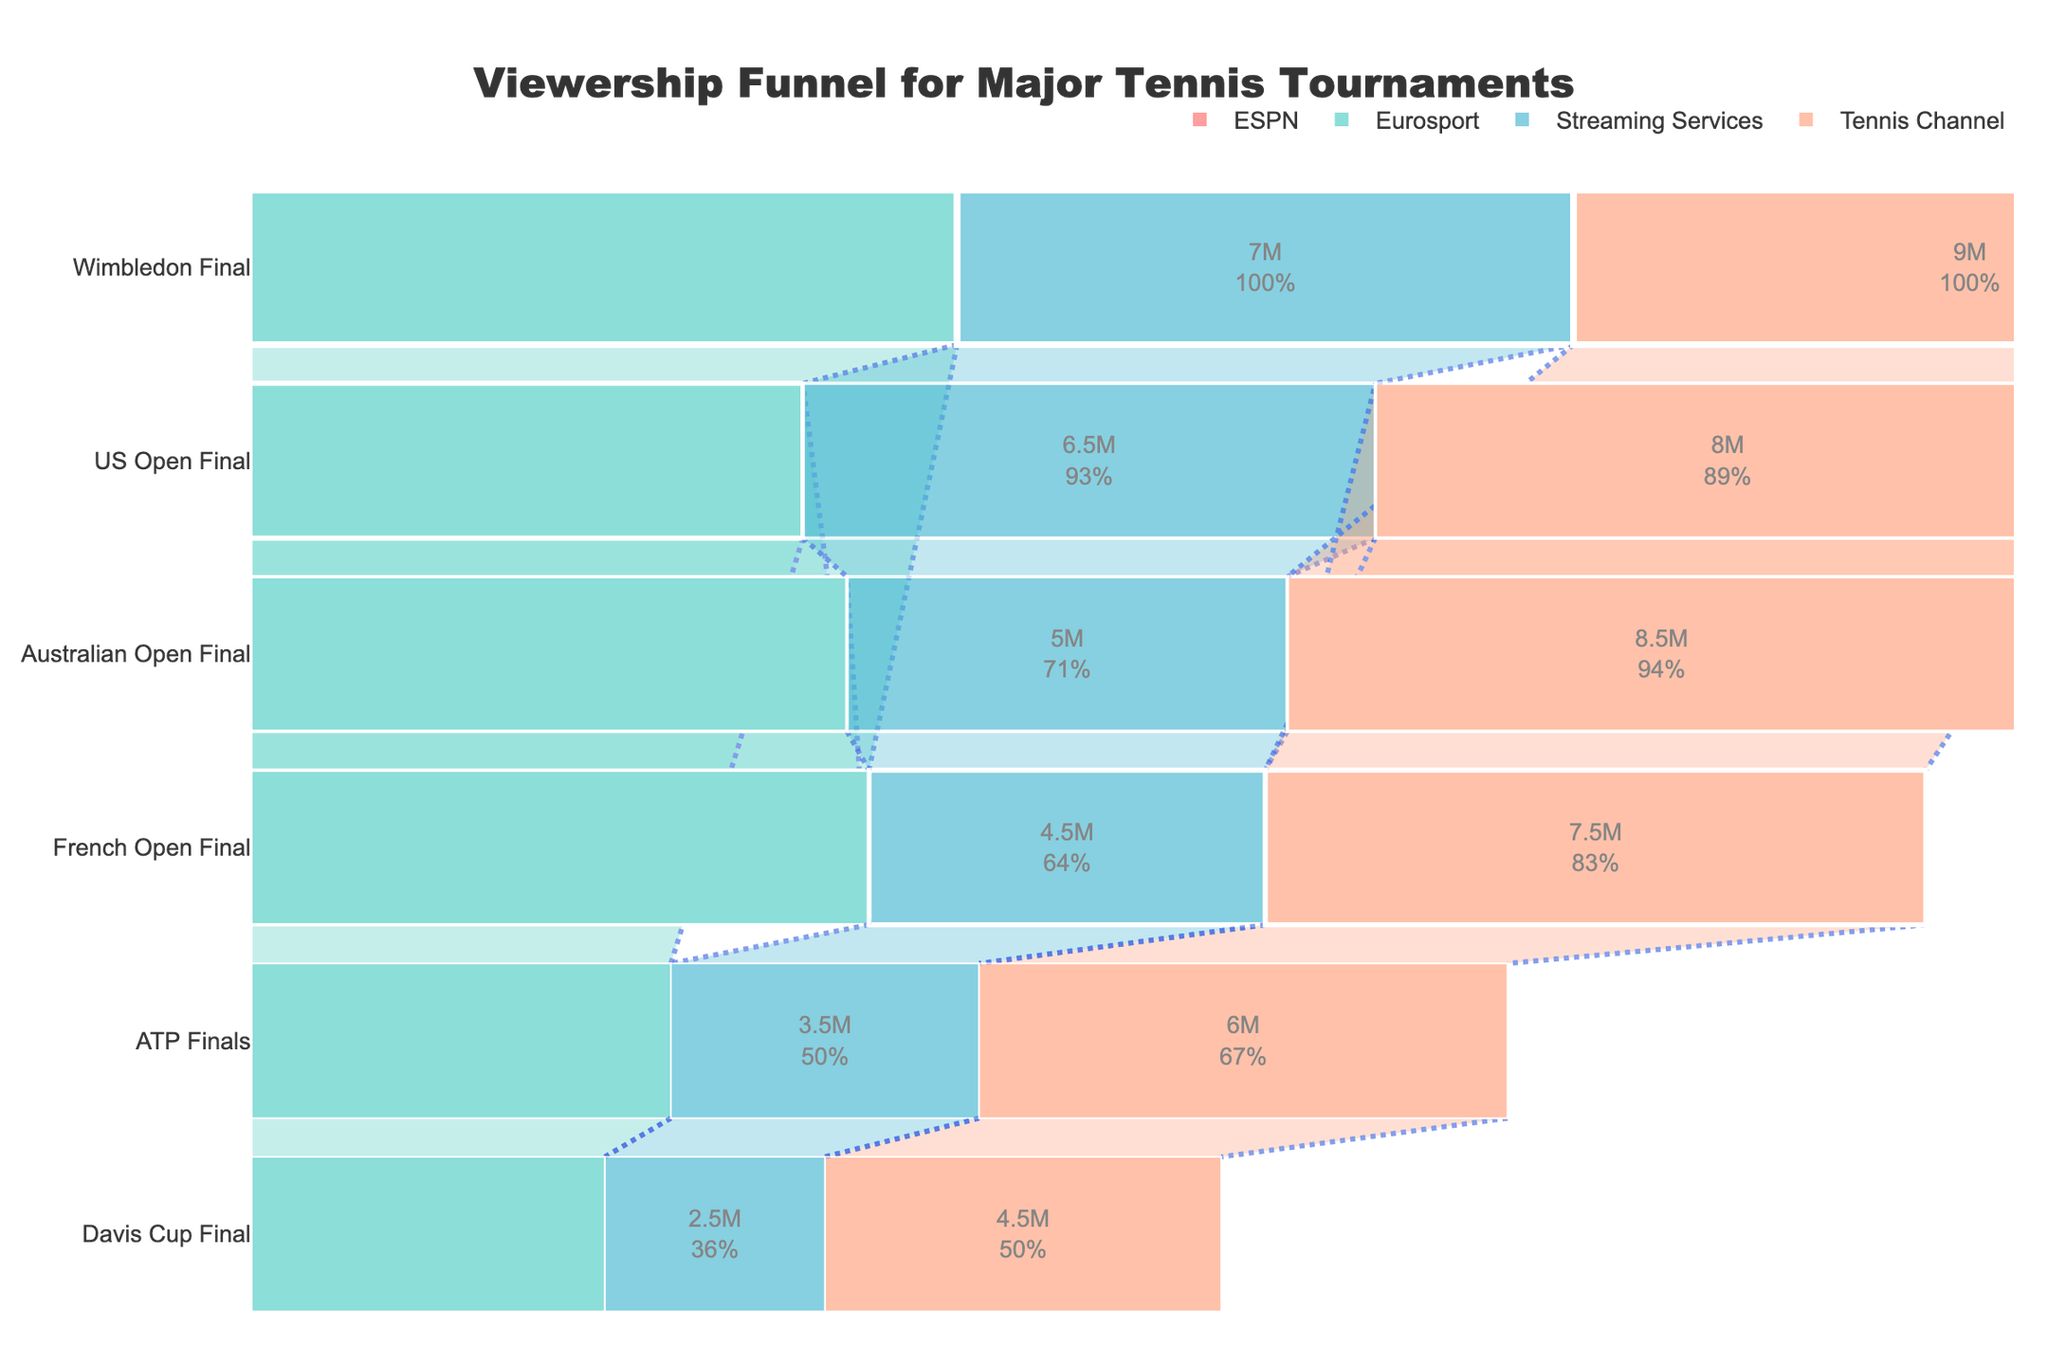which tournament had the highest viewership on Eurosport? First, observe the stages and their corresponding viewership values for Eurosport. The stage with the maximum viewership is the Wimbledon Final
Answer: Wimbledon Final what is the difference in viewership between the French Open Final and Davis Cup Final on ESPN? Identify the viewership of the French Open Final on ESPN (10,000,000) and the Davis Cup Final on ESPN (6,000,000). Subtract the later from the former: 10,000,000 - 6,000,000 = 4,000,000
Answer: 4,000,000 which broadcasting platform had the lowest viewership for the ATP Finals? For the ATP Finals, note the viewership across different platforms. The lowest value is on Streaming Services with 3,500,000
Answer: Streaming Services how many unique stages are shown in the funnel chart? Each stage represents a different tennis tournament's final. Counting the unique stages listed, we have Australian Open Final, Wimbledon Final, US Open Final, French Open Final, ATP Finals, and Davis Cup Final, which makes 6 unique stages
Answer: 6 which tournament had the most balanced viewership across all platforms? Examine viewership values for each platform for all tournaments. The US Open Final has relatively similar viewership numbers: ESPN (13,000,000), Tennis Channel (8,000,000), Eurosport (14,000,000), and Streaming Services (6,500,000), showing it's the most balanced
Answer: US Open Final what is the total viewership for the Wimbledon Final across all platforms? Sum the viewership of the Wimbledon Final from ESPN (14,000,000), Tennis Channel (9,000,000), Eurosport (18,000,000), and Streaming Services (7,000,000). The total viewership is 14,000,000 + 9,000,000 + 18,000,000 + 7,000,000 = 48,000,000
Answer: 48,000,000 which stage showed the greatest drop in viewers from ESPN to Tennis Channel? Calculate the difference in viewership from ESPN to Tennis Channel for each stage. The Australian Open Final has the greatest drop: 12,000,000 (ESPN) - 8,500,000 (Tennis Channel) = 3,500,000
Answer: Australian Open Final does Eurosport consistently have the highest viewership for all stages? Compare Eurosport's viewership with other platforms for each stage. Eurosport does not consistently have the highest viewership; for the ATP Finals, ESPN has the highest viewership of 8,000,000 compared to Eurosport's 11,000,000
Answer: No what is the average viewership of the French Open Final across all platforms? Sum the viewership numbers of the French Open Final across all platforms: ESPN (10,000,000), Tennis Channel (7,500,000), Eurosport (16,000,000), Streaming Services (4,500,000). The total viewership is 10,000,000 + 7,500,000 + 16,000,000 + 4,500,000 = 38,000,000. The average is 38,000,000 / 4 = 9,500,000
Answer: 9,500,000 